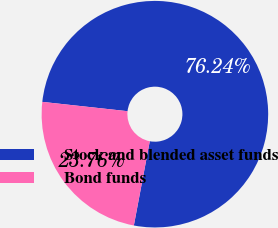Convert chart to OTSL. <chart><loc_0><loc_0><loc_500><loc_500><pie_chart><fcel>Stock and blended asset funds<fcel>Bond funds<nl><fcel>76.24%<fcel>23.76%<nl></chart> 